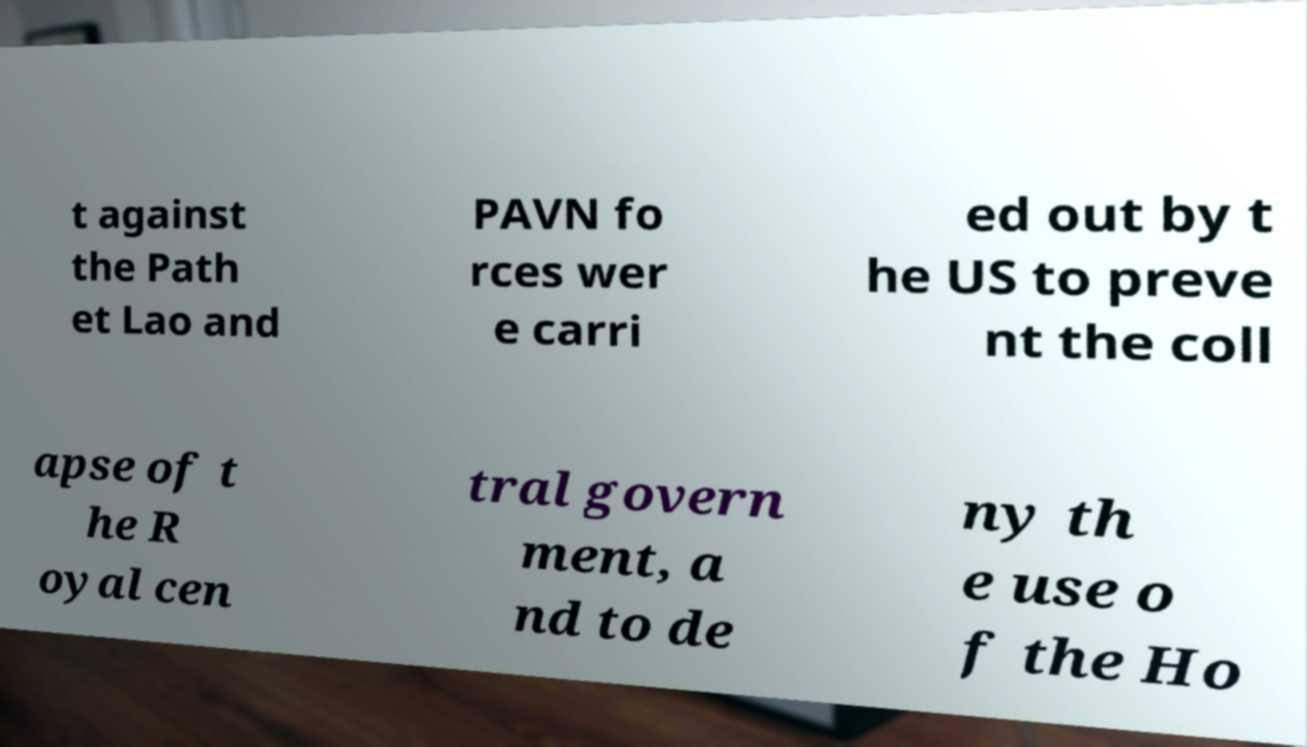What messages or text are displayed in this image? I need them in a readable, typed format. t against the Path et Lao and PAVN fo rces wer e carri ed out by t he US to preve nt the coll apse of t he R oyal cen tral govern ment, a nd to de ny th e use o f the Ho 